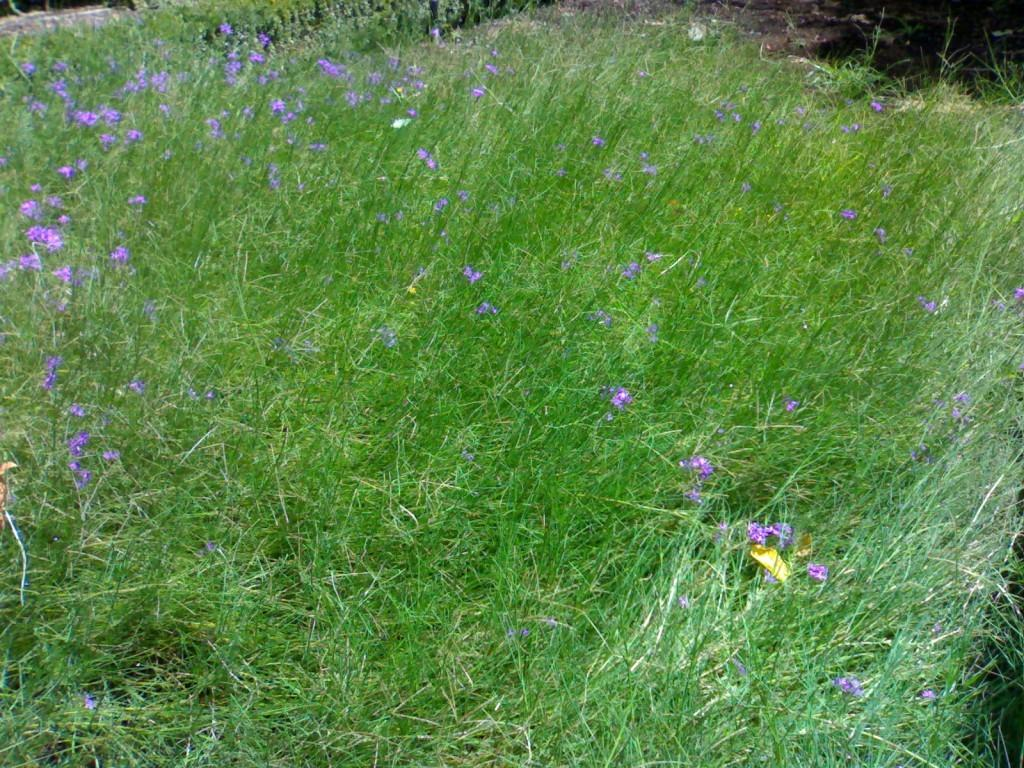What type of vegetation can be seen in the image? There is grass and flowers in the image. Can you describe the ground in the image? The ground is visible at the top right corner of the image. What type of soda is being poured into the grass in the image? There is no soda present in the image, and no pouring is taking place. 